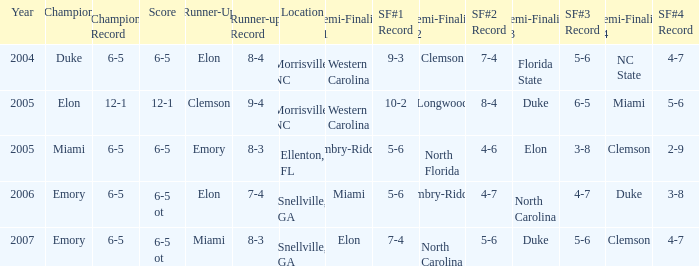List the scores of all games when Miami were listed as the first Semi finalist 6-5 ot. 